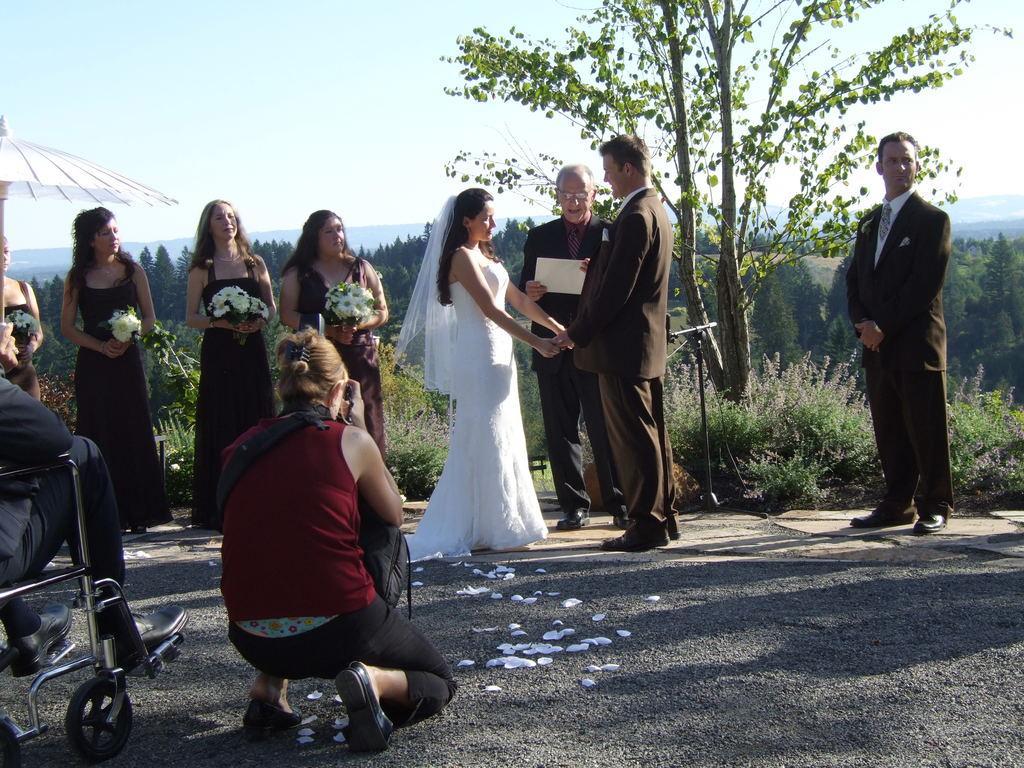How would you summarize this image in a sentence or two? In this image I can see a woman wearing white colored dress and a person wearing blazer and pant are standing and holding hands. In the background I can see few other persons standing and holding flower bouquets, a person standing and holding a paper, a woman sitting and holding a camera, a white colored umbrella, few trees, few mountains and the sky. 